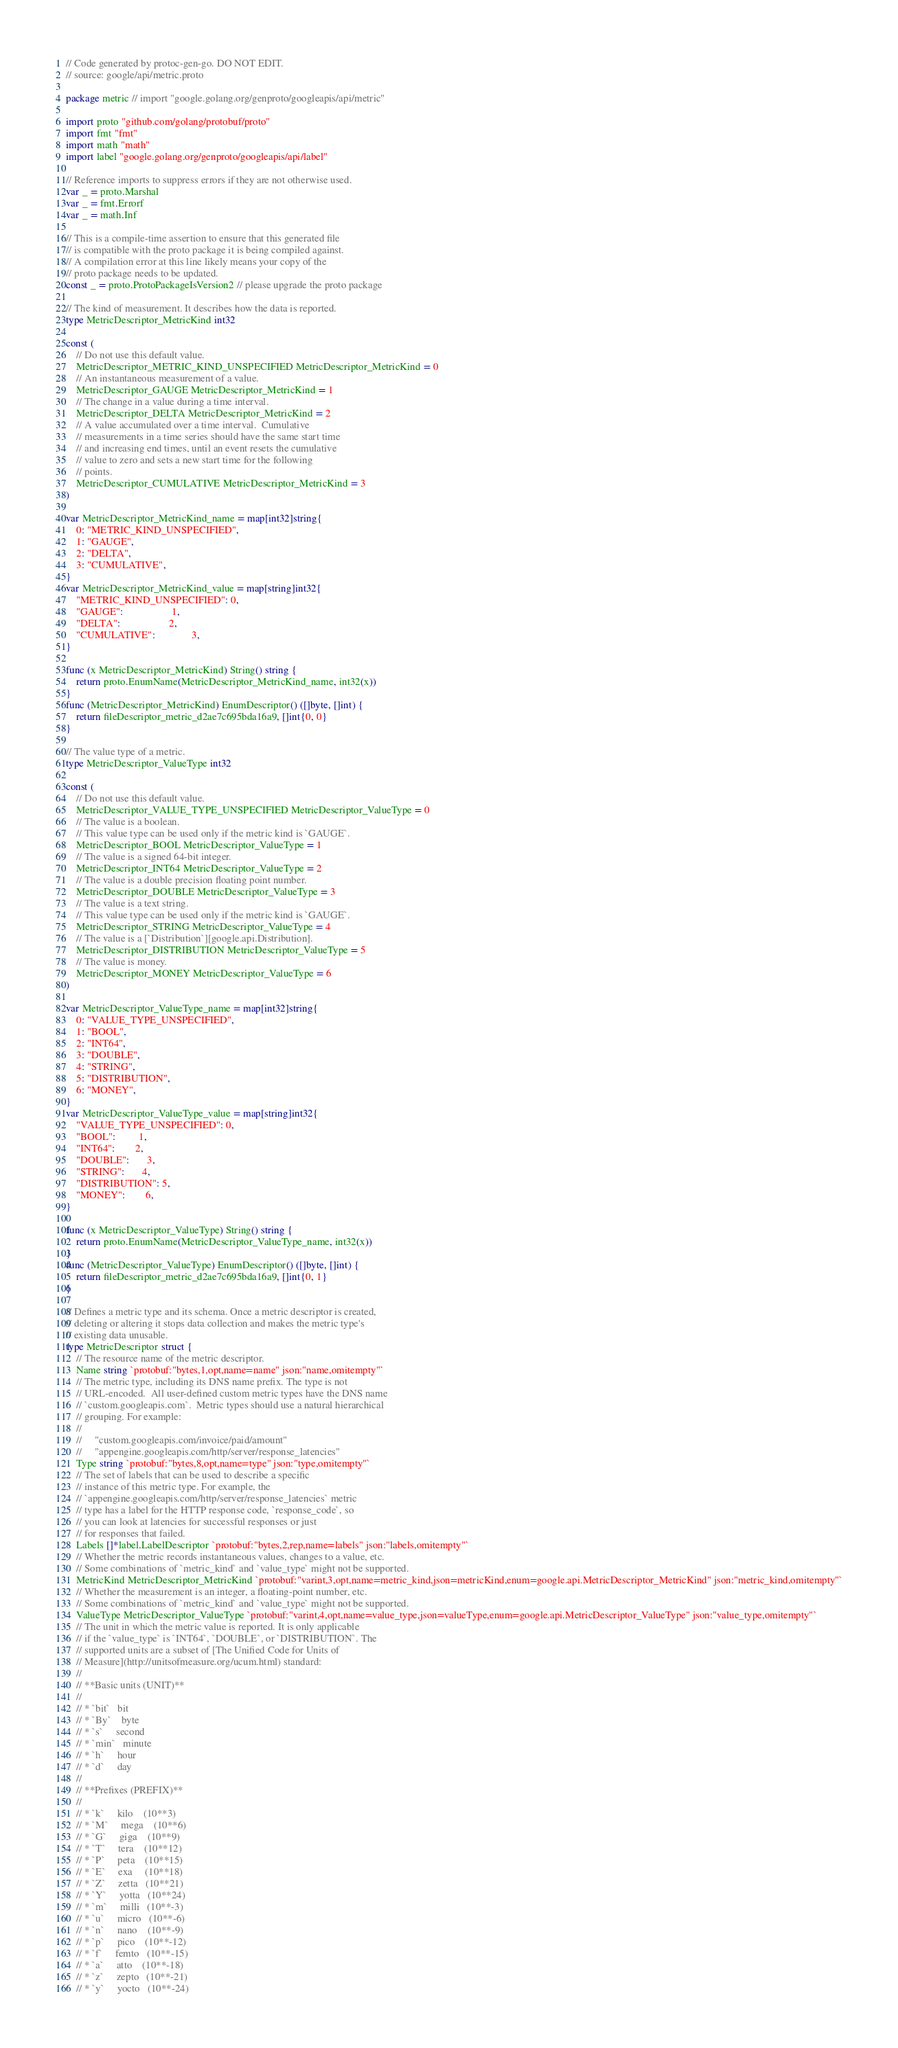<code> <loc_0><loc_0><loc_500><loc_500><_Go_>// Code generated by protoc-gen-go. DO NOT EDIT.
// source: google/api/metric.proto

package metric // import "google.golang.org/genproto/googleapis/api/metric"

import proto "github.com/golang/protobuf/proto"
import fmt "fmt"
import math "math"
import label "google.golang.org/genproto/googleapis/api/label"

// Reference imports to suppress errors if they are not otherwise used.
var _ = proto.Marshal
var _ = fmt.Errorf
var _ = math.Inf

// This is a compile-time assertion to ensure that this generated file
// is compatible with the proto package it is being compiled against.
// A compilation error at this line likely means your copy of the
// proto package needs to be updated.
const _ = proto.ProtoPackageIsVersion2 // please upgrade the proto package

// The kind of measurement. It describes how the data is reported.
type MetricDescriptor_MetricKind int32

const (
	// Do not use this default value.
	MetricDescriptor_METRIC_KIND_UNSPECIFIED MetricDescriptor_MetricKind = 0
	// An instantaneous measurement of a value.
	MetricDescriptor_GAUGE MetricDescriptor_MetricKind = 1
	// The change in a value during a time interval.
	MetricDescriptor_DELTA MetricDescriptor_MetricKind = 2
	// A value accumulated over a time interval.  Cumulative
	// measurements in a time series should have the same start time
	// and increasing end times, until an event resets the cumulative
	// value to zero and sets a new start time for the following
	// points.
	MetricDescriptor_CUMULATIVE MetricDescriptor_MetricKind = 3
)

var MetricDescriptor_MetricKind_name = map[int32]string{
	0: "METRIC_KIND_UNSPECIFIED",
	1: "GAUGE",
	2: "DELTA",
	3: "CUMULATIVE",
}
var MetricDescriptor_MetricKind_value = map[string]int32{
	"METRIC_KIND_UNSPECIFIED": 0,
	"GAUGE":                   1,
	"DELTA":                   2,
	"CUMULATIVE":              3,
}

func (x MetricDescriptor_MetricKind) String() string {
	return proto.EnumName(MetricDescriptor_MetricKind_name, int32(x))
}
func (MetricDescriptor_MetricKind) EnumDescriptor() ([]byte, []int) {
	return fileDescriptor_metric_d2ae7c695bda16a9, []int{0, 0}
}

// The value type of a metric.
type MetricDescriptor_ValueType int32

const (
	// Do not use this default value.
	MetricDescriptor_VALUE_TYPE_UNSPECIFIED MetricDescriptor_ValueType = 0
	// The value is a boolean.
	// This value type can be used only if the metric kind is `GAUGE`.
	MetricDescriptor_BOOL MetricDescriptor_ValueType = 1
	// The value is a signed 64-bit integer.
	MetricDescriptor_INT64 MetricDescriptor_ValueType = 2
	// The value is a double precision floating point number.
	MetricDescriptor_DOUBLE MetricDescriptor_ValueType = 3
	// The value is a text string.
	// This value type can be used only if the metric kind is `GAUGE`.
	MetricDescriptor_STRING MetricDescriptor_ValueType = 4
	// The value is a [`Distribution`][google.api.Distribution].
	MetricDescriptor_DISTRIBUTION MetricDescriptor_ValueType = 5
	// The value is money.
	MetricDescriptor_MONEY MetricDescriptor_ValueType = 6
)

var MetricDescriptor_ValueType_name = map[int32]string{
	0: "VALUE_TYPE_UNSPECIFIED",
	1: "BOOL",
	2: "INT64",
	3: "DOUBLE",
	4: "STRING",
	5: "DISTRIBUTION",
	6: "MONEY",
}
var MetricDescriptor_ValueType_value = map[string]int32{
	"VALUE_TYPE_UNSPECIFIED": 0,
	"BOOL":         1,
	"INT64":        2,
	"DOUBLE":       3,
	"STRING":       4,
	"DISTRIBUTION": 5,
	"MONEY":        6,
}

func (x MetricDescriptor_ValueType) String() string {
	return proto.EnumName(MetricDescriptor_ValueType_name, int32(x))
}
func (MetricDescriptor_ValueType) EnumDescriptor() ([]byte, []int) {
	return fileDescriptor_metric_d2ae7c695bda16a9, []int{0, 1}
}

// Defines a metric type and its schema. Once a metric descriptor is created,
// deleting or altering it stops data collection and makes the metric type's
// existing data unusable.
type MetricDescriptor struct {
	// The resource name of the metric descriptor.
	Name string `protobuf:"bytes,1,opt,name=name" json:"name,omitempty"`
	// The metric type, including its DNS name prefix. The type is not
	// URL-encoded.  All user-defined custom metric types have the DNS name
	// `custom.googleapis.com`.  Metric types should use a natural hierarchical
	// grouping. For example:
	//
	//     "custom.googleapis.com/invoice/paid/amount"
	//     "appengine.googleapis.com/http/server/response_latencies"
	Type string `protobuf:"bytes,8,opt,name=type" json:"type,omitempty"`
	// The set of labels that can be used to describe a specific
	// instance of this metric type. For example, the
	// `appengine.googleapis.com/http/server/response_latencies` metric
	// type has a label for the HTTP response code, `response_code`, so
	// you can look at latencies for successful responses or just
	// for responses that failed.
	Labels []*label.LabelDescriptor `protobuf:"bytes,2,rep,name=labels" json:"labels,omitempty"`
	// Whether the metric records instantaneous values, changes to a value, etc.
	// Some combinations of `metric_kind` and `value_type` might not be supported.
	MetricKind MetricDescriptor_MetricKind `protobuf:"varint,3,opt,name=metric_kind,json=metricKind,enum=google.api.MetricDescriptor_MetricKind" json:"metric_kind,omitempty"`
	// Whether the measurement is an integer, a floating-point number, etc.
	// Some combinations of `metric_kind` and `value_type` might not be supported.
	ValueType MetricDescriptor_ValueType `protobuf:"varint,4,opt,name=value_type,json=valueType,enum=google.api.MetricDescriptor_ValueType" json:"value_type,omitempty"`
	// The unit in which the metric value is reported. It is only applicable
	// if the `value_type` is `INT64`, `DOUBLE`, or `DISTRIBUTION`. The
	// supported units are a subset of [The Unified Code for Units of
	// Measure](http://unitsofmeasure.org/ucum.html) standard:
	//
	// **Basic units (UNIT)**
	//
	// * `bit`   bit
	// * `By`    byte
	// * `s`     second
	// * `min`   minute
	// * `h`     hour
	// * `d`     day
	//
	// **Prefixes (PREFIX)**
	//
	// * `k`     kilo    (10**3)
	// * `M`     mega    (10**6)
	// * `G`     giga    (10**9)
	// * `T`     tera    (10**12)
	// * `P`     peta    (10**15)
	// * `E`     exa     (10**18)
	// * `Z`     zetta   (10**21)
	// * `Y`     yotta   (10**24)
	// * `m`     milli   (10**-3)
	// * `u`     micro   (10**-6)
	// * `n`     nano    (10**-9)
	// * `p`     pico    (10**-12)
	// * `f`     femto   (10**-15)
	// * `a`     atto    (10**-18)
	// * `z`     zepto   (10**-21)
	// * `y`     yocto   (10**-24)</code> 